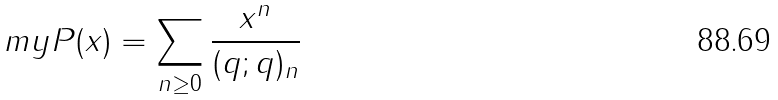<formula> <loc_0><loc_0><loc_500><loc_500>\ m y P ( x ) = \sum _ { n \geq 0 } \frac { x ^ { n } } { ( q ; q ) _ { n } }</formula> 